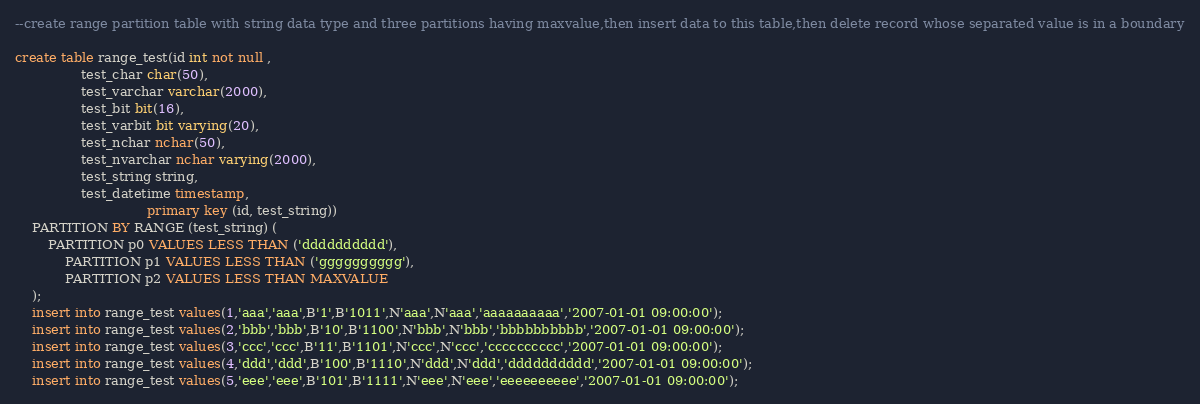Convert code to text. <code><loc_0><loc_0><loc_500><loc_500><_SQL_>--create range partition table with string data type and three partitions having maxvalue,then insert data to this table,then delete record whose separated value is in a boundary

create table range_test(id int not null ,
				test_char char(50),
				test_varchar varchar(2000),
				test_bit bit(16),
				test_varbit bit varying(20),
				test_nchar nchar(50),
				test_nvarchar nchar varying(2000),
				test_string string,
				test_datetime timestamp,
                                primary key (id, test_string))
	PARTITION BY RANGE (test_string) (
	    PARTITION p0 VALUES LESS THAN ('dddddddddd'),
    	    PARTITION p1 VALUES LESS THAN ('gggggggggg'),
    	    PARTITION p2 VALUES LESS THAN MAXVALUE
	);
	insert into range_test values(1,'aaa','aaa',B'1',B'1011',N'aaa',N'aaa','aaaaaaaaaa','2007-01-01 09:00:00');
	insert into range_test values(2,'bbb','bbb',B'10',B'1100',N'bbb',N'bbb','bbbbbbbbbb','2007-01-01 09:00:00');
	insert into range_test values(3,'ccc','ccc',B'11',B'1101',N'ccc',N'ccc','cccccccccc','2007-01-01 09:00:00');
	insert into range_test values(4,'ddd','ddd',B'100',B'1110',N'ddd',N'ddd','dddddddddd','2007-01-01 09:00:00');
	insert into range_test values(5,'eee','eee',B'101',B'1111',N'eee',N'eee','eeeeeeeeee','2007-01-01 09:00:00');</code> 